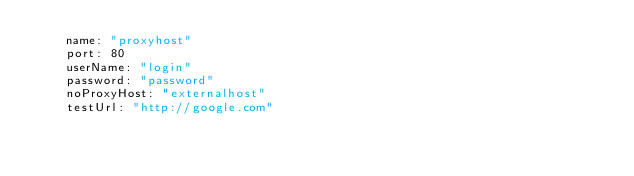<code> <loc_0><loc_0><loc_500><loc_500><_YAML_>    name: "proxyhost"
    port: 80
    userName: "login"
    password: "password"
    noProxyHost: "externalhost"
    testUrl: "http://google.com"</code> 